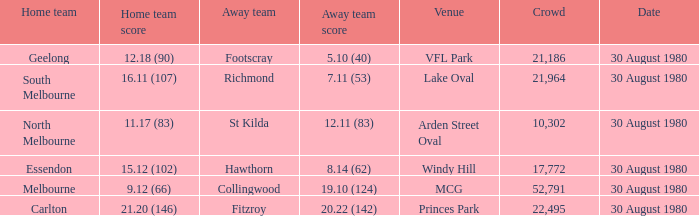What was the score for south melbourne at home? 16.11 (107). 